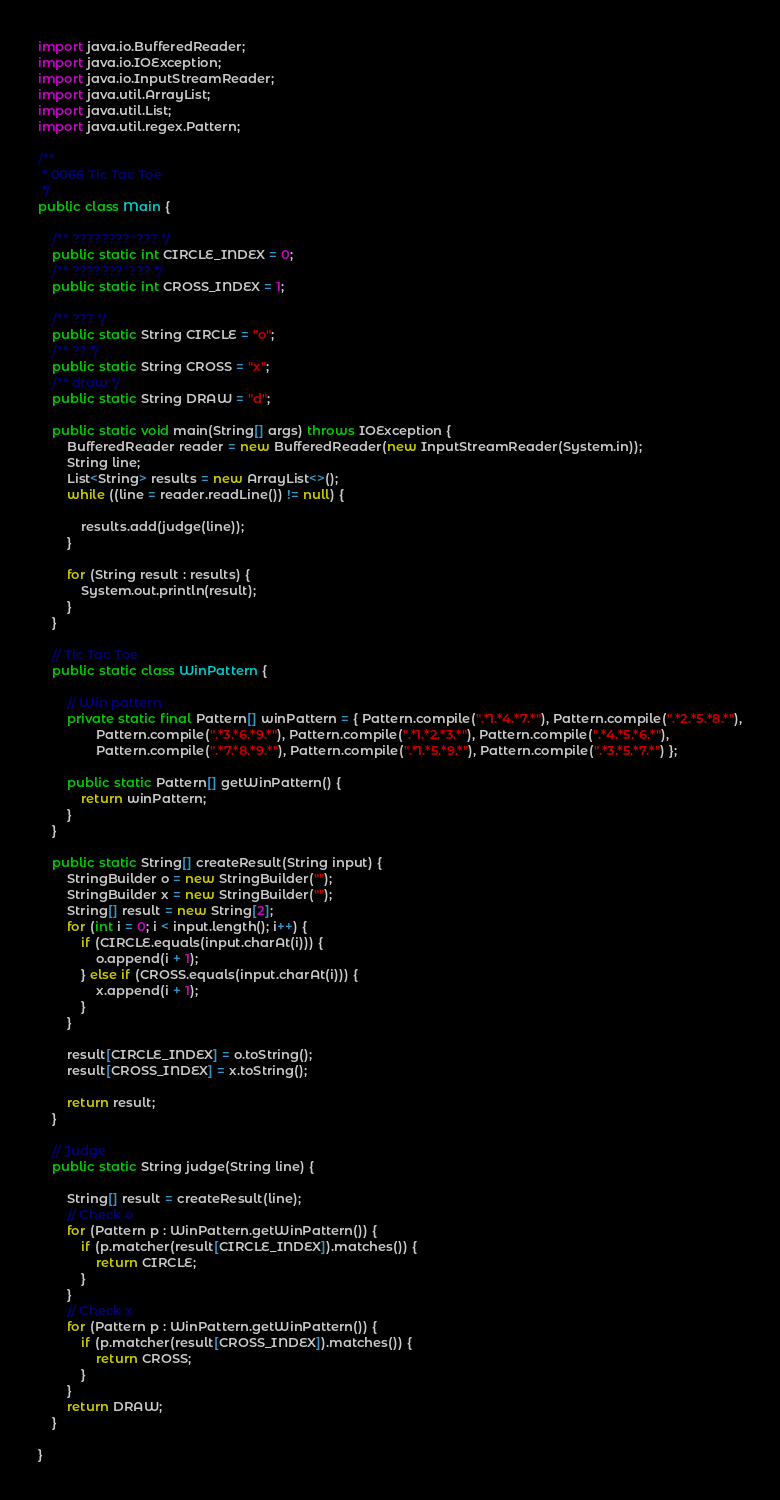<code> <loc_0><loc_0><loc_500><loc_500><_Java_>import java.io.BufferedReader;
import java.io.IOException;
import java.io.InputStreamReader;
import java.util.ArrayList;
import java.util.List;
import java.util.regex.Pattern;

/**
 * 0066 Tic Tac Toe
 */
public class Main {

    /** ????????°??? */
    public static int CIRCLE_INDEX = 0;
    /** ???????°??? */
    public static int CROSS_INDEX = 1;

    /** ??? */
    public static String CIRCLE = "o";
    /** ?? */
    public static String CROSS = "x";
    /** draw */
    public static String DRAW = "d";

    public static void main(String[] args) throws IOException {
        BufferedReader reader = new BufferedReader(new InputStreamReader(System.in));
        String line;
        List<String> results = new ArrayList<>();
        while ((line = reader.readLine()) != null) {

            results.add(judge(line));
        }

        for (String result : results) {
            System.out.println(result);
        }
    }

    // Tic Tac Toe
    public static class WinPattern {

        // Win pattern
        private static final Pattern[] winPattern = { Pattern.compile(".*1.*4.*7.*"), Pattern.compile(".*2.*5.*8.*"),
                Pattern.compile(".*3.*6.*9.*"), Pattern.compile(".*1.*2.*3.*"), Pattern.compile(".*4.*5.*6.*"),
                Pattern.compile(".*7.*8.*9.*"), Pattern.compile(".*1.*5.*9.*"), Pattern.compile(".*3.*5.*7.*") };

        public static Pattern[] getWinPattern() {
            return winPattern;
        }
    }

    public static String[] createResult(String input) {
        StringBuilder o = new StringBuilder("");
        StringBuilder x = new StringBuilder("");
        String[] result = new String[2];
        for (int i = 0; i < input.length(); i++) {
            if (CIRCLE.equals(input.charAt(i))) {
                o.append(i + 1);
            } else if (CROSS.equals(input.charAt(i))) {
                x.append(i + 1);
            }
        }

        result[CIRCLE_INDEX] = o.toString();
        result[CROSS_INDEX] = x.toString();

        return result;
    }

    // Judge
    public static String judge(String line) {

        String[] result = createResult(line);
        // Check o
        for (Pattern p : WinPattern.getWinPattern()) {
            if (p.matcher(result[CIRCLE_INDEX]).matches()) {
                return CIRCLE;
            }
        }
        // Check x
        for (Pattern p : WinPattern.getWinPattern()) {
            if (p.matcher(result[CROSS_INDEX]).matches()) {
                return CROSS;
            }
        }
        return DRAW;
    }

}</code> 